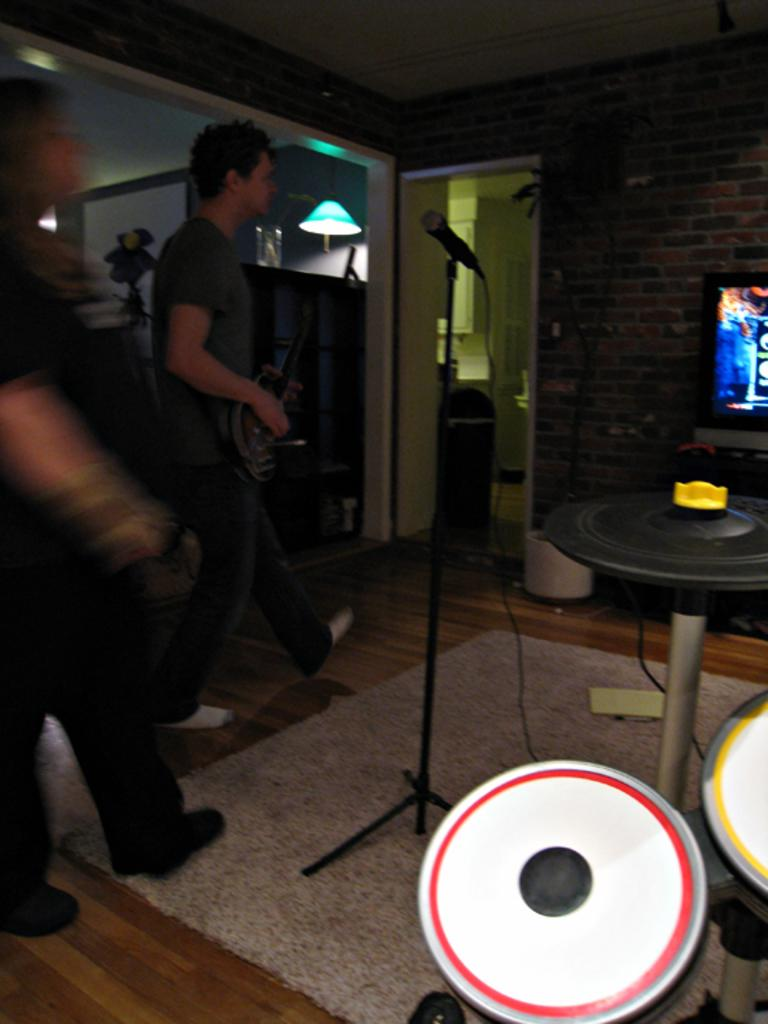What object is used for amplifying sound in the image? There is a mic in the image, which is used for amplifying sound. How many persons are in the image? There are persons in the image, but the exact number is not specified. What type of structure can be seen in the image? There is a wall and a door in the image. What electronic device is present in the image? There is a television in the image. What objects are used for creating music in the image? There are musical instruments in the image. What piece of furniture is present in the image? There is a table in the image. What source of illumination is visible in the image? There is a light in the image. What type of scissors are being used to cut the skin in the image? There are no scissors or skin present in the image. What is the point of the image? The purpose or point of the image is not specified in the provided facts. 